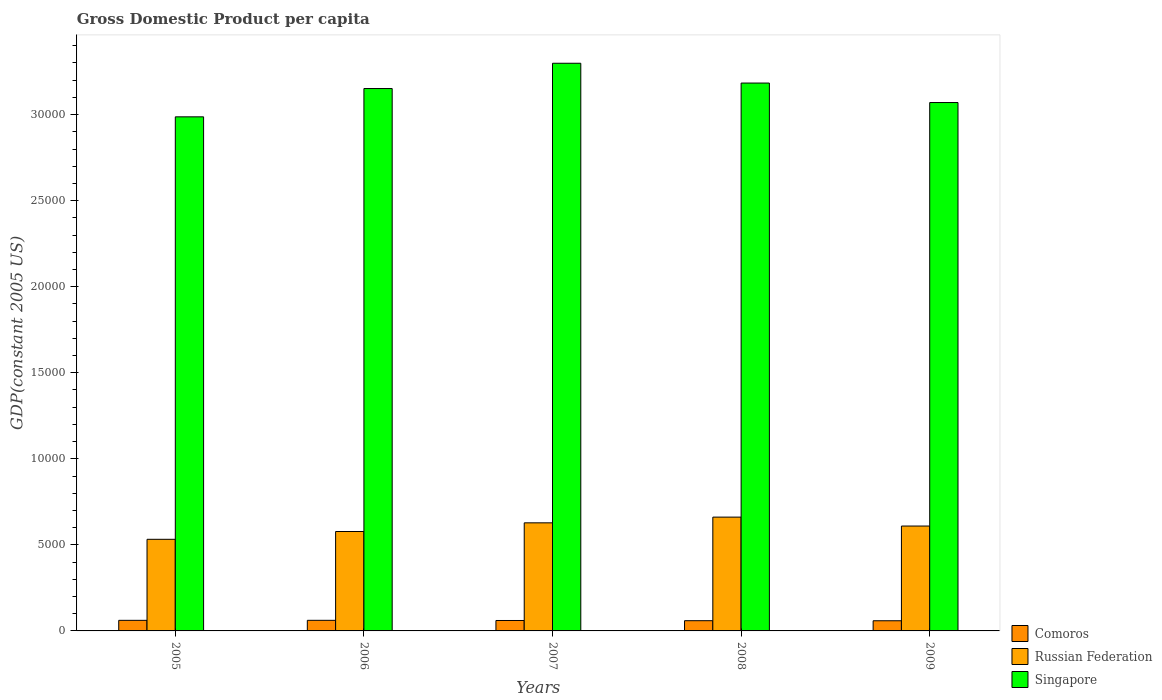How many different coloured bars are there?
Offer a terse response. 3. Are the number of bars on each tick of the X-axis equal?
Your answer should be very brief. Yes. How many bars are there on the 5th tick from the left?
Your response must be concise. 3. How many bars are there on the 3rd tick from the right?
Ensure brevity in your answer.  3. What is the label of the 3rd group of bars from the left?
Keep it short and to the point. 2007. In how many cases, is the number of bars for a given year not equal to the number of legend labels?
Offer a terse response. 0. What is the GDP per capita in Singapore in 2007?
Offer a very short reply. 3.30e+04. Across all years, what is the maximum GDP per capita in Comoros?
Give a very brief answer. 616.02. Across all years, what is the minimum GDP per capita in Singapore?
Your answer should be compact. 2.99e+04. In which year was the GDP per capita in Russian Federation maximum?
Provide a short and direct response. 2008. What is the total GDP per capita in Singapore in the graph?
Make the answer very short. 1.57e+05. What is the difference between the GDP per capita in Comoros in 2006 and that in 2008?
Ensure brevity in your answer.  22.19. What is the difference between the GDP per capita in Singapore in 2009 and the GDP per capita in Comoros in 2006?
Offer a very short reply. 3.01e+04. What is the average GDP per capita in Singapore per year?
Your answer should be very brief. 3.14e+04. In the year 2006, what is the difference between the GDP per capita in Singapore and GDP per capita in Comoros?
Offer a very short reply. 3.09e+04. In how many years, is the GDP per capita in Comoros greater than 27000 US$?
Your answer should be very brief. 0. What is the ratio of the GDP per capita in Comoros in 2005 to that in 2007?
Keep it short and to the point. 1.01. Is the GDP per capita in Comoros in 2005 less than that in 2009?
Offer a very short reply. No. What is the difference between the highest and the second highest GDP per capita in Singapore?
Provide a short and direct response. 1150.27. What is the difference between the highest and the lowest GDP per capita in Singapore?
Make the answer very short. 3113.34. In how many years, is the GDP per capita in Singapore greater than the average GDP per capita in Singapore taken over all years?
Your response must be concise. 3. Is the sum of the GDP per capita in Singapore in 2007 and 2008 greater than the maximum GDP per capita in Comoros across all years?
Offer a very short reply. Yes. What does the 1st bar from the left in 2006 represents?
Keep it short and to the point. Comoros. What does the 2nd bar from the right in 2007 represents?
Keep it short and to the point. Russian Federation. Is it the case that in every year, the sum of the GDP per capita in Russian Federation and GDP per capita in Singapore is greater than the GDP per capita in Comoros?
Make the answer very short. Yes. How many bars are there?
Provide a succinct answer. 15. How many years are there in the graph?
Keep it short and to the point. 5. Does the graph contain any zero values?
Keep it short and to the point. No. Where does the legend appear in the graph?
Ensure brevity in your answer.  Bottom right. How many legend labels are there?
Provide a succinct answer. 3. How are the legend labels stacked?
Ensure brevity in your answer.  Vertical. What is the title of the graph?
Your answer should be compact. Gross Domestic Product per capita. What is the label or title of the X-axis?
Give a very brief answer. Years. What is the label or title of the Y-axis?
Give a very brief answer. GDP(constant 2005 US). What is the GDP(constant 2005 US) of Comoros in 2005?
Ensure brevity in your answer.  614.86. What is the GDP(constant 2005 US) of Russian Federation in 2005?
Your answer should be very brief. 5323.47. What is the GDP(constant 2005 US) of Singapore in 2005?
Your response must be concise. 2.99e+04. What is the GDP(constant 2005 US) of Comoros in 2006?
Your answer should be compact. 616.02. What is the GDP(constant 2005 US) of Russian Federation in 2006?
Keep it short and to the point. 5776.4. What is the GDP(constant 2005 US) in Singapore in 2006?
Provide a short and direct response. 3.15e+04. What is the GDP(constant 2005 US) of Comoros in 2007?
Your answer should be very brief. 606.04. What is the GDP(constant 2005 US) in Russian Federation in 2007?
Give a very brief answer. 6280.15. What is the GDP(constant 2005 US) of Singapore in 2007?
Provide a short and direct response. 3.30e+04. What is the GDP(constant 2005 US) in Comoros in 2008?
Your response must be concise. 593.83. What is the GDP(constant 2005 US) in Russian Federation in 2008?
Ensure brevity in your answer.  6612.63. What is the GDP(constant 2005 US) of Singapore in 2008?
Your answer should be compact. 3.18e+04. What is the GDP(constant 2005 US) in Comoros in 2009?
Offer a very short reply. 590.82. What is the GDP(constant 2005 US) of Russian Federation in 2009?
Give a very brief answer. 6093.63. What is the GDP(constant 2005 US) of Singapore in 2009?
Offer a very short reply. 3.07e+04. Across all years, what is the maximum GDP(constant 2005 US) of Comoros?
Ensure brevity in your answer.  616.02. Across all years, what is the maximum GDP(constant 2005 US) of Russian Federation?
Your answer should be very brief. 6612.63. Across all years, what is the maximum GDP(constant 2005 US) in Singapore?
Give a very brief answer. 3.30e+04. Across all years, what is the minimum GDP(constant 2005 US) in Comoros?
Keep it short and to the point. 590.82. Across all years, what is the minimum GDP(constant 2005 US) in Russian Federation?
Your answer should be very brief. 5323.47. Across all years, what is the minimum GDP(constant 2005 US) of Singapore?
Make the answer very short. 2.99e+04. What is the total GDP(constant 2005 US) in Comoros in the graph?
Ensure brevity in your answer.  3021.56. What is the total GDP(constant 2005 US) in Russian Federation in the graph?
Make the answer very short. 3.01e+04. What is the total GDP(constant 2005 US) in Singapore in the graph?
Provide a short and direct response. 1.57e+05. What is the difference between the GDP(constant 2005 US) in Comoros in 2005 and that in 2006?
Make the answer very short. -1.16. What is the difference between the GDP(constant 2005 US) of Russian Federation in 2005 and that in 2006?
Keep it short and to the point. -452.92. What is the difference between the GDP(constant 2005 US) of Singapore in 2005 and that in 2006?
Keep it short and to the point. -1644.74. What is the difference between the GDP(constant 2005 US) in Comoros in 2005 and that in 2007?
Provide a succinct answer. 8.82. What is the difference between the GDP(constant 2005 US) in Russian Federation in 2005 and that in 2007?
Keep it short and to the point. -956.67. What is the difference between the GDP(constant 2005 US) in Singapore in 2005 and that in 2007?
Offer a terse response. -3113.34. What is the difference between the GDP(constant 2005 US) in Comoros in 2005 and that in 2008?
Keep it short and to the point. 21.03. What is the difference between the GDP(constant 2005 US) in Russian Federation in 2005 and that in 2008?
Your answer should be very brief. -1289.16. What is the difference between the GDP(constant 2005 US) of Singapore in 2005 and that in 2008?
Provide a succinct answer. -1963.07. What is the difference between the GDP(constant 2005 US) in Comoros in 2005 and that in 2009?
Provide a short and direct response. 24.04. What is the difference between the GDP(constant 2005 US) in Russian Federation in 2005 and that in 2009?
Give a very brief answer. -770.16. What is the difference between the GDP(constant 2005 US) in Singapore in 2005 and that in 2009?
Your answer should be very brief. -830.84. What is the difference between the GDP(constant 2005 US) of Comoros in 2006 and that in 2007?
Offer a very short reply. 9.98. What is the difference between the GDP(constant 2005 US) in Russian Federation in 2006 and that in 2007?
Offer a very short reply. -503.75. What is the difference between the GDP(constant 2005 US) in Singapore in 2006 and that in 2007?
Ensure brevity in your answer.  -1468.61. What is the difference between the GDP(constant 2005 US) of Comoros in 2006 and that in 2008?
Provide a succinct answer. 22.19. What is the difference between the GDP(constant 2005 US) of Russian Federation in 2006 and that in 2008?
Your answer should be compact. -836.24. What is the difference between the GDP(constant 2005 US) of Singapore in 2006 and that in 2008?
Make the answer very short. -318.33. What is the difference between the GDP(constant 2005 US) in Comoros in 2006 and that in 2009?
Offer a very short reply. 25.2. What is the difference between the GDP(constant 2005 US) of Russian Federation in 2006 and that in 2009?
Your answer should be very brief. -317.23. What is the difference between the GDP(constant 2005 US) in Singapore in 2006 and that in 2009?
Your response must be concise. 813.9. What is the difference between the GDP(constant 2005 US) in Comoros in 2007 and that in 2008?
Give a very brief answer. 12.21. What is the difference between the GDP(constant 2005 US) of Russian Federation in 2007 and that in 2008?
Provide a short and direct response. -332.48. What is the difference between the GDP(constant 2005 US) of Singapore in 2007 and that in 2008?
Offer a very short reply. 1150.27. What is the difference between the GDP(constant 2005 US) in Comoros in 2007 and that in 2009?
Make the answer very short. 15.22. What is the difference between the GDP(constant 2005 US) in Russian Federation in 2007 and that in 2009?
Your response must be concise. 186.52. What is the difference between the GDP(constant 2005 US) of Singapore in 2007 and that in 2009?
Offer a terse response. 2282.51. What is the difference between the GDP(constant 2005 US) in Comoros in 2008 and that in 2009?
Ensure brevity in your answer.  3.01. What is the difference between the GDP(constant 2005 US) of Russian Federation in 2008 and that in 2009?
Give a very brief answer. 519. What is the difference between the GDP(constant 2005 US) in Singapore in 2008 and that in 2009?
Keep it short and to the point. 1132.23. What is the difference between the GDP(constant 2005 US) in Comoros in 2005 and the GDP(constant 2005 US) in Russian Federation in 2006?
Offer a very short reply. -5161.53. What is the difference between the GDP(constant 2005 US) of Comoros in 2005 and the GDP(constant 2005 US) of Singapore in 2006?
Ensure brevity in your answer.  -3.09e+04. What is the difference between the GDP(constant 2005 US) in Russian Federation in 2005 and the GDP(constant 2005 US) in Singapore in 2006?
Your answer should be very brief. -2.62e+04. What is the difference between the GDP(constant 2005 US) of Comoros in 2005 and the GDP(constant 2005 US) of Russian Federation in 2007?
Provide a succinct answer. -5665.29. What is the difference between the GDP(constant 2005 US) of Comoros in 2005 and the GDP(constant 2005 US) of Singapore in 2007?
Offer a very short reply. -3.24e+04. What is the difference between the GDP(constant 2005 US) in Russian Federation in 2005 and the GDP(constant 2005 US) in Singapore in 2007?
Your response must be concise. -2.77e+04. What is the difference between the GDP(constant 2005 US) of Comoros in 2005 and the GDP(constant 2005 US) of Russian Federation in 2008?
Keep it short and to the point. -5997.77. What is the difference between the GDP(constant 2005 US) of Comoros in 2005 and the GDP(constant 2005 US) of Singapore in 2008?
Offer a terse response. -3.12e+04. What is the difference between the GDP(constant 2005 US) in Russian Federation in 2005 and the GDP(constant 2005 US) in Singapore in 2008?
Ensure brevity in your answer.  -2.65e+04. What is the difference between the GDP(constant 2005 US) of Comoros in 2005 and the GDP(constant 2005 US) of Russian Federation in 2009?
Give a very brief answer. -5478.77. What is the difference between the GDP(constant 2005 US) of Comoros in 2005 and the GDP(constant 2005 US) of Singapore in 2009?
Your response must be concise. -3.01e+04. What is the difference between the GDP(constant 2005 US) of Russian Federation in 2005 and the GDP(constant 2005 US) of Singapore in 2009?
Offer a terse response. -2.54e+04. What is the difference between the GDP(constant 2005 US) of Comoros in 2006 and the GDP(constant 2005 US) of Russian Federation in 2007?
Give a very brief answer. -5664.13. What is the difference between the GDP(constant 2005 US) of Comoros in 2006 and the GDP(constant 2005 US) of Singapore in 2007?
Your answer should be compact. -3.24e+04. What is the difference between the GDP(constant 2005 US) in Russian Federation in 2006 and the GDP(constant 2005 US) in Singapore in 2007?
Offer a terse response. -2.72e+04. What is the difference between the GDP(constant 2005 US) in Comoros in 2006 and the GDP(constant 2005 US) in Russian Federation in 2008?
Ensure brevity in your answer.  -5996.61. What is the difference between the GDP(constant 2005 US) in Comoros in 2006 and the GDP(constant 2005 US) in Singapore in 2008?
Provide a succinct answer. -3.12e+04. What is the difference between the GDP(constant 2005 US) of Russian Federation in 2006 and the GDP(constant 2005 US) of Singapore in 2008?
Your answer should be very brief. -2.61e+04. What is the difference between the GDP(constant 2005 US) in Comoros in 2006 and the GDP(constant 2005 US) in Russian Federation in 2009?
Your answer should be compact. -5477.61. What is the difference between the GDP(constant 2005 US) of Comoros in 2006 and the GDP(constant 2005 US) of Singapore in 2009?
Provide a succinct answer. -3.01e+04. What is the difference between the GDP(constant 2005 US) in Russian Federation in 2006 and the GDP(constant 2005 US) in Singapore in 2009?
Make the answer very short. -2.49e+04. What is the difference between the GDP(constant 2005 US) in Comoros in 2007 and the GDP(constant 2005 US) in Russian Federation in 2008?
Your answer should be very brief. -6006.59. What is the difference between the GDP(constant 2005 US) in Comoros in 2007 and the GDP(constant 2005 US) in Singapore in 2008?
Your response must be concise. -3.12e+04. What is the difference between the GDP(constant 2005 US) in Russian Federation in 2007 and the GDP(constant 2005 US) in Singapore in 2008?
Offer a very short reply. -2.56e+04. What is the difference between the GDP(constant 2005 US) in Comoros in 2007 and the GDP(constant 2005 US) in Russian Federation in 2009?
Make the answer very short. -5487.59. What is the difference between the GDP(constant 2005 US) of Comoros in 2007 and the GDP(constant 2005 US) of Singapore in 2009?
Give a very brief answer. -3.01e+04. What is the difference between the GDP(constant 2005 US) in Russian Federation in 2007 and the GDP(constant 2005 US) in Singapore in 2009?
Ensure brevity in your answer.  -2.44e+04. What is the difference between the GDP(constant 2005 US) of Comoros in 2008 and the GDP(constant 2005 US) of Russian Federation in 2009?
Give a very brief answer. -5499.8. What is the difference between the GDP(constant 2005 US) in Comoros in 2008 and the GDP(constant 2005 US) in Singapore in 2009?
Provide a short and direct response. -3.01e+04. What is the difference between the GDP(constant 2005 US) of Russian Federation in 2008 and the GDP(constant 2005 US) of Singapore in 2009?
Provide a short and direct response. -2.41e+04. What is the average GDP(constant 2005 US) of Comoros per year?
Ensure brevity in your answer.  604.31. What is the average GDP(constant 2005 US) in Russian Federation per year?
Your response must be concise. 6017.26. What is the average GDP(constant 2005 US) of Singapore per year?
Keep it short and to the point. 3.14e+04. In the year 2005, what is the difference between the GDP(constant 2005 US) in Comoros and GDP(constant 2005 US) in Russian Federation?
Your response must be concise. -4708.61. In the year 2005, what is the difference between the GDP(constant 2005 US) of Comoros and GDP(constant 2005 US) of Singapore?
Provide a succinct answer. -2.93e+04. In the year 2005, what is the difference between the GDP(constant 2005 US) in Russian Federation and GDP(constant 2005 US) in Singapore?
Give a very brief answer. -2.45e+04. In the year 2006, what is the difference between the GDP(constant 2005 US) in Comoros and GDP(constant 2005 US) in Russian Federation?
Provide a succinct answer. -5160.38. In the year 2006, what is the difference between the GDP(constant 2005 US) of Comoros and GDP(constant 2005 US) of Singapore?
Offer a very short reply. -3.09e+04. In the year 2006, what is the difference between the GDP(constant 2005 US) in Russian Federation and GDP(constant 2005 US) in Singapore?
Your response must be concise. -2.57e+04. In the year 2007, what is the difference between the GDP(constant 2005 US) of Comoros and GDP(constant 2005 US) of Russian Federation?
Make the answer very short. -5674.11. In the year 2007, what is the difference between the GDP(constant 2005 US) in Comoros and GDP(constant 2005 US) in Singapore?
Your response must be concise. -3.24e+04. In the year 2007, what is the difference between the GDP(constant 2005 US) in Russian Federation and GDP(constant 2005 US) in Singapore?
Ensure brevity in your answer.  -2.67e+04. In the year 2008, what is the difference between the GDP(constant 2005 US) of Comoros and GDP(constant 2005 US) of Russian Federation?
Your answer should be very brief. -6018.81. In the year 2008, what is the difference between the GDP(constant 2005 US) of Comoros and GDP(constant 2005 US) of Singapore?
Provide a succinct answer. -3.12e+04. In the year 2008, what is the difference between the GDP(constant 2005 US) in Russian Federation and GDP(constant 2005 US) in Singapore?
Your answer should be compact. -2.52e+04. In the year 2009, what is the difference between the GDP(constant 2005 US) in Comoros and GDP(constant 2005 US) in Russian Federation?
Make the answer very short. -5502.81. In the year 2009, what is the difference between the GDP(constant 2005 US) in Comoros and GDP(constant 2005 US) in Singapore?
Provide a succinct answer. -3.01e+04. In the year 2009, what is the difference between the GDP(constant 2005 US) of Russian Federation and GDP(constant 2005 US) of Singapore?
Offer a terse response. -2.46e+04. What is the ratio of the GDP(constant 2005 US) of Russian Federation in 2005 to that in 2006?
Offer a terse response. 0.92. What is the ratio of the GDP(constant 2005 US) in Singapore in 2005 to that in 2006?
Your answer should be very brief. 0.95. What is the ratio of the GDP(constant 2005 US) of Comoros in 2005 to that in 2007?
Provide a short and direct response. 1.01. What is the ratio of the GDP(constant 2005 US) of Russian Federation in 2005 to that in 2007?
Keep it short and to the point. 0.85. What is the ratio of the GDP(constant 2005 US) in Singapore in 2005 to that in 2007?
Offer a very short reply. 0.91. What is the ratio of the GDP(constant 2005 US) in Comoros in 2005 to that in 2008?
Ensure brevity in your answer.  1.04. What is the ratio of the GDP(constant 2005 US) in Russian Federation in 2005 to that in 2008?
Your answer should be compact. 0.81. What is the ratio of the GDP(constant 2005 US) of Singapore in 2005 to that in 2008?
Provide a succinct answer. 0.94. What is the ratio of the GDP(constant 2005 US) of Comoros in 2005 to that in 2009?
Provide a short and direct response. 1.04. What is the ratio of the GDP(constant 2005 US) of Russian Federation in 2005 to that in 2009?
Ensure brevity in your answer.  0.87. What is the ratio of the GDP(constant 2005 US) in Singapore in 2005 to that in 2009?
Keep it short and to the point. 0.97. What is the ratio of the GDP(constant 2005 US) of Comoros in 2006 to that in 2007?
Provide a succinct answer. 1.02. What is the ratio of the GDP(constant 2005 US) in Russian Federation in 2006 to that in 2007?
Provide a succinct answer. 0.92. What is the ratio of the GDP(constant 2005 US) of Singapore in 2006 to that in 2007?
Provide a short and direct response. 0.96. What is the ratio of the GDP(constant 2005 US) of Comoros in 2006 to that in 2008?
Provide a succinct answer. 1.04. What is the ratio of the GDP(constant 2005 US) in Russian Federation in 2006 to that in 2008?
Your answer should be compact. 0.87. What is the ratio of the GDP(constant 2005 US) in Singapore in 2006 to that in 2008?
Your response must be concise. 0.99. What is the ratio of the GDP(constant 2005 US) in Comoros in 2006 to that in 2009?
Ensure brevity in your answer.  1.04. What is the ratio of the GDP(constant 2005 US) in Russian Federation in 2006 to that in 2009?
Make the answer very short. 0.95. What is the ratio of the GDP(constant 2005 US) of Singapore in 2006 to that in 2009?
Provide a succinct answer. 1.03. What is the ratio of the GDP(constant 2005 US) of Comoros in 2007 to that in 2008?
Your answer should be compact. 1.02. What is the ratio of the GDP(constant 2005 US) of Russian Federation in 2007 to that in 2008?
Your answer should be compact. 0.95. What is the ratio of the GDP(constant 2005 US) in Singapore in 2007 to that in 2008?
Provide a short and direct response. 1.04. What is the ratio of the GDP(constant 2005 US) in Comoros in 2007 to that in 2009?
Offer a very short reply. 1.03. What is the ratio of the GDP(constant 2005 US) of Russian Federation in 2007 to that in 2009?
Your answer should be compact. 1.03. What is the ratio of the GDP(constant 2005 US) of Singapore in 2007 to that in 2009?
Your answer should be very brief. 1.07. What is the ratio of the GDP(constant 2005 US) of Russian Federation in 2008 to that in 2009?
Give a very brief answer. 1.09. What is the ratio of the GDP(constant 2005 US) of Singapore in 2008 to that in 2009?
Your response must be concise. 1.04. What is the difference between the highest and the second highest GDP(constant 2005 US) in Comoros?
Provide a short and direct response. 1.16. What is the difference between the highest and the second highest GDP(constant 2005 US) in Russian Federation?
Provide a succinct answer. 332.48. What is the difference between the highest and the second highest GDP(constant 2005 US) of Singapore?
Offer a terse response. 1150.27. What is the difference between the highest and the lowest GDP(constant 2005 US) in Comoros?
Your response must be concise. 25.2. What is the difference between the highest and the lowest GDP(constant 2005 US) in Russian Federation?
Your answer should be compact. 1289.16. What is the difference between the highest and the lowest GDP(constant 2005 US) in Singapore?
Give a very brief answer. 3113.34. 